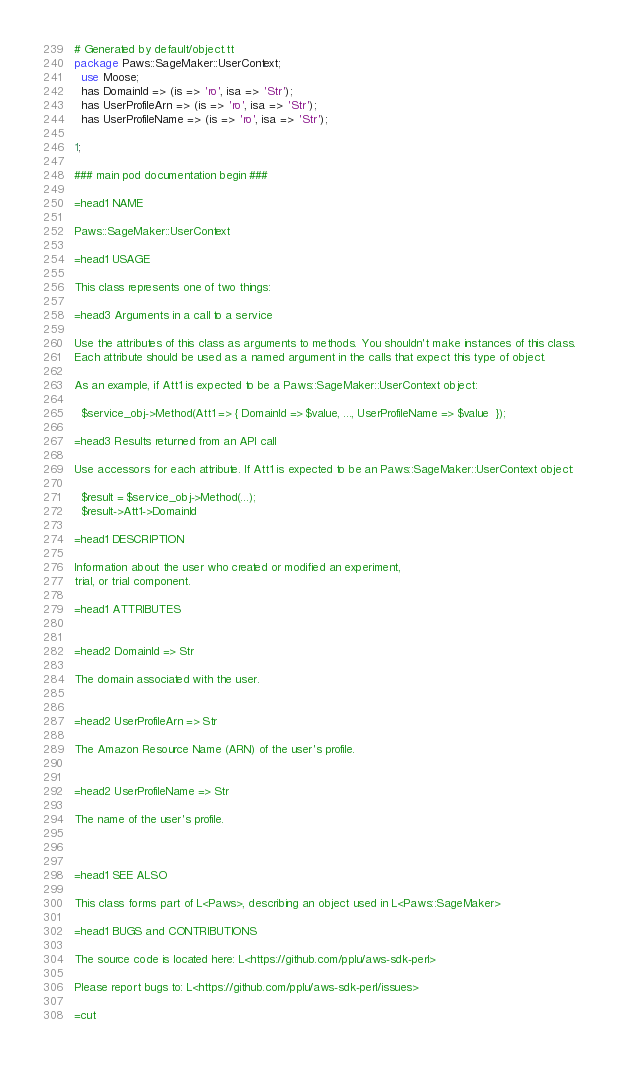<code> <loc_0><loc_0><loc_500><loc_500><_Perl_># Generated by default/object.tt
package Paws::SageMaker::UserContext;
  use Moose;
  has DomainId => (is => 'ro', isa => 'Str');
  has UserProfileArn => (is => 'ro', isa => 'Str');
  has UserProfileName => (is => 'ro', isa => 'Str');

1;

### main pod documentation begin ###

=head1 NAME

Paws::SageMaker::UserContext

=head1 USAGE

This class represents one of two things:

=head3 Arguments in a call to a service

Use the attributes of this class as arguments to methods. You shouldn't make instances of this class. 
Each attribute should be used as a named argument in the calls that expect this type of object.

As an example, if Att1 is expected to be a Paws::SageMaker::UserContext object:

  $service_obj->Method(Att1 => { DomainId => $value, ..., UserProfileName => $value  });

=head3 Results returned from an API call

Use accessors for each attribute. If Att1 is expected to be an Paws::SageMaker::UserContext object:

  $result = $service_obj->Method(...);
  $result->Att1->DomainId

=head1 DESCRIPTION

Information about the user who created or modified an experiment,
trial, or trial component.

=head1 ATTRIBUTES


=head2 DomainId => Str

The domain associated with the user.


=head2 UserProfileArn => Str

The Amazon Resource Name (ARN) of the user's profile.


=head2 UserProfileName => Str

The name of the user's profile.



=head1 SEE ALSO

This class forms part of L<Paws>, describing an object used in L<Paws::SageMaker>

=head1 BUGS and CONTRIBUTIONS

The source code is located here: L<https://github.com/pplu/aws-sdk-perl>

Please report bugs to: L<https://github.com/pplu/aws-sdk-perl/issues>

=cut

</code> 